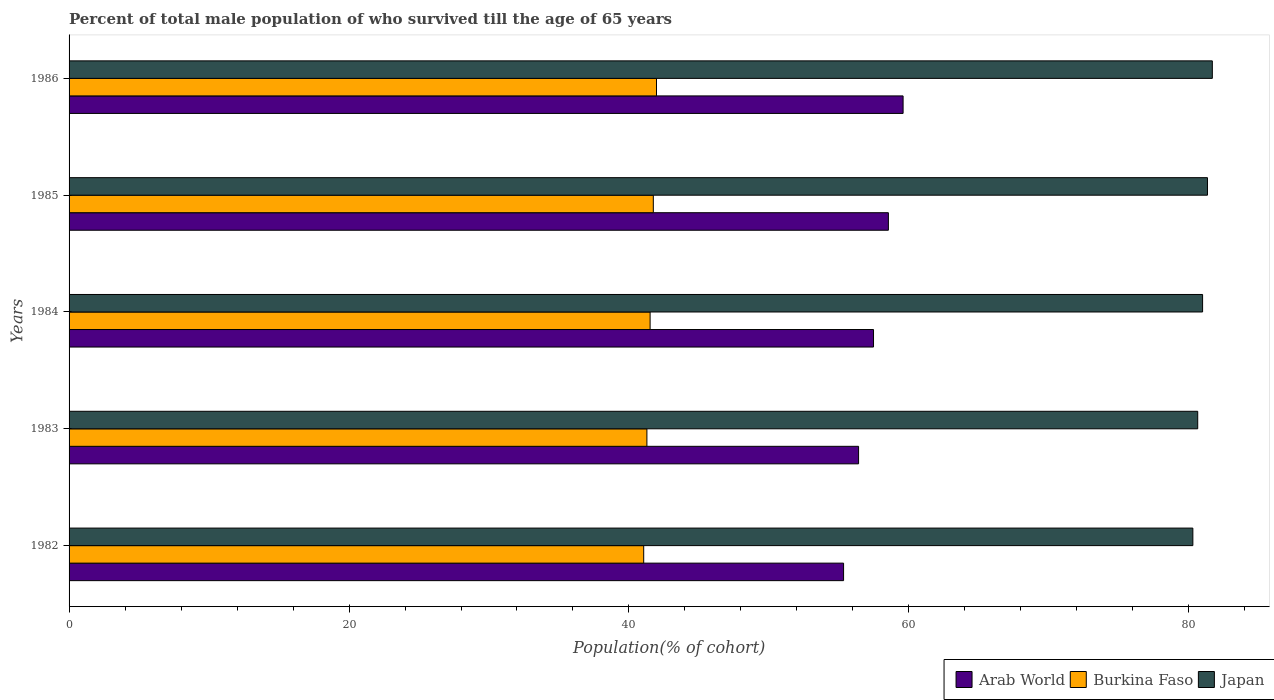Are the number of bars on each tick of the Y-axis equal?
Provide a short and direct response. Yes. How many bars are there on the 5th tick from the top?
Provide a succinct answer. 3. What is the label of the 3rd group of bars from the top?
Provide a succinct answer. 1984. What is the percentage of total male population who survived till the age of 65 years in Japan in 1985?
Ensure brevity in your answer.  81.33. Across all years, what is the maximum percentage of total male population who survived till the age of 65 years in Burkina Faso?
Provide a succinct answer. 41.97. Across all years, what is the minimum percentage of total male population who survived till the age of 65 years in Arab World?
Offer a terse response. 55.33. In which year was the percentage of total male population who survived till the age of 65 years in Japan maximum?
Offer a very short reply. 1986. What is the total percentage of total male population who survived till the age of 65 years in Arab World in the graph?
Offer a terse response. 287.32. What is the difference between the percentage of total male population who survived till the age of 65 years in Burkina Faso in 1984 and that in 1986?
Offer a very short reply. -0.46. What is the difference between the percentage of total male population who survived till the age of 65 years in Burkina Faso in 1983 and the percentage of total male population who survived till the age of 65 years in Japan in 1982?
Your answer should be very brief. -39. What is the average percentage of total male population who survived till the age of 65 years in Arab World per year?
Give a very brief answer. 57.46. In the year 1986, what is the difference between the percentage of total male population who survived till the age of 65 years in Burkina Faso and percentage of total male population who survived till the age of 65 years in Arab World?
Your answer should be compact. -17.62. What is the ratio of the percentage of total male population who survived till the age of 65 years in Arab World in 1982 to that in 1984?
Ensure brevity in your answer.  0.96. What is the difference between the highest and the second highest percentage of total male population who survived till the age of 65 years in Japan?
Keep it short and to the point. 0.35. What is the difference between the highest and the lowest percentage of total male population who survived till the age of 65 years in Arab World?
Provide a short and direct response. 4.25. Is it the case that in every year, the sum of the percentage of total male population who survived till the age of 65 years in Arab World and percentage of total male population who survived till the age of 65 years in Burkina Faso is greater than the percentage of total male population who survived till the age of 65 years in Japan?
Offer a terse response. Yes. Are the values on the major ticks of X-axis written in scientific E-notation?
Provide a succinct answer. No. Does the graph contain any zero values?
Offer a terse response. No. Does the graph contain grids?
Provide a short and direct response. No. Where does the legend appear in the graph?
Offer a very short reply. Bottom right. How many legend labels are there?
Keep it short and to the point. 3. How are the legend labels stacked?
Offer a terse response. Horizontal. What is the title of the graph?
Your answer should be compact. Percent of total male population of who survived till the age of 65 years. Does "Bahrain" appear as one of the legend labels in the graph?
Give a very brief answer. No. What is the label or title of the X-axis?
Provide a short and direct response. Population(% of cohort). What is the label or title of the Y-axis?
Ensure brevity in your answer.  Years. What is the Population(% of cohort) of Arab World in 1982?
Your answer should be very brief. 55.33. What is the Population(% of cohort) of Burkina Faso in 1982?
Provide a short and direct response. 41.05. What is the Population(% of cohort) in Japan in 1982?
Your answer should be compact. 80.29. What is the Population(% of cohort) in Arab World in 1983?
Make the answer very short. 56.4. What is the Population(% of cohort) of Burkina Faso in 1983?
Your answer should be very brief. 41.28. What is the Population(% of cohort) of Japan in 1983?
Keep it short and to the point. 80.63. What is the Population(% of cohort) of Arab World in 1984?
Provide a succinct answer. 57.47. What is the Population(% of cohort) in Burkina Faso in 1984?
Your answer should be compact. 41.51. What is the Population(% of cohort) in Japan in 1984?
Provide a short and direct response. 80.98. What is the Population(% of cohort) in Arab World in 1985?
Make the answer very short. 58.53. What is the Population(% of cohort) in Burkina Faso in 1985?
Provide a short and direct response. 41.74. What is the Population(% of cohort) of Japan in 1985?
Provide a short and direct response. 81.33. What is the Population(% of cohort) of Arab World in 1986?
Offer a very short reply. 59.58. What is the Population(% of cohort) in Burkina Faso in 1986?
Offer a very short reply. 41.97. What is the Population(% of cohort) of Japan in 1986?
Make the answer very short. 81.68. Across all years, what is the maximum Population(% of cohort) in Arab World?
Your answer should be compact. 59.58. Across all years, what is the maximum Population(% of cohort) of Burkina Faso?
Give a very brief answer. 41.97. Across all years, what is the maximum Population(% of cohort) of Japan?
Give a very brief answer. 81.68. Across all years, what is the minimum Population(% of cohort) of Arab World?
Provide a succinct answer. 55.33. Across all years, what is the minimum Population(% of cohort) in Burkina Faso?
Your response must be concise. 41.05. Across all years, what is the minimum Population(% of cohort) in Japan?
Offer a terse response. 80.29. What is the total Population(% of cohort) in Arab World in the graph?
Offer a terse response. 287.32. What is the total Population(% of cohort) in Burkina Faso in the graph?
Provide a short and direct response. 207.55. What is the total Population(% of cohort) of Japan in the graph?
Your response must be concise. 404.9. What is the difference between the Population(% of cohort) in Arab World in 1982 and that in 1983?
Provide a short and direct response. -1.07. What is the difference between the Population(% of cohort) in Burkina Faso in 1982 and that in 1983?
Provide a short and direct response. -0.23. What is the difference between the Population(% of cohort) of Japan in 1982 and that in 1983?
Your answer should be compact. -0.35. What is the difference between the Population(% of cohort) of Arab World in 1982 and that in 1984?
Offer a very short reply. -2.14. What is the difference between the Population(% of cohort) of Burkina Faso in 1982 and that in 1984?
Offer a very short reply. -0.46. What is the difference between the Population(% of cohort) in Japan in 1982 and that in 1984?
Your response must be concise. -0.7. What is the difference between the Population(% of cohort) in Arab World in 1982 and that in 1985?
Your answer should be very brief. -3.2. What is the difference between the Population(% of cohort) of Burkina Faso in 1982 and that in 1985?
Keep it short and to the point. -0.69. What is the difference between the Population(% of cohort) in Japan in 1982 and that in 1985?
Keep it short and to the point. -1.04. What is the difference between the Population(% of cohort) of Arab World in 1982 and that in 1986?
Offer a terse response. -4.25. What is the difference between the Population(% of cohort) in Burkina Faso in 1982 and that in 1986?
Keep it short and to the point. -0.91. What is the difference between the Population(% of cohort) of Japan in 1982 and that in 1986?
Provide a succinct answer. -1.39. What is the difference between the Population(% of cohort) of Arab World in 1983 and that in 1984?
Your answer should be very brief. -1.07. What is the difference between the Population(% of cohort) in Burkina Faso in 1983 and that in 1984?
Your answer should be compact. -0.23. What is the difference between the Population(% of cohort) of Japan in 1983 and that in 1984?
Provide a succinct answer. -0.35. What is the difference between the Population(% of cohort) in Arab World in 1983 and that in 1985?
Give a very brief answer. -2.13. What is the difference between the Population(% of cohort) of Burkina Faso in 1983 and that in 1985?
Keep it short and to the point. -0.46. What is the difference between the Population(% of cohort) in Japan in 1983 and that in 1985?
Provide a short and direct response. -0.7. What is the difference between the Population(% of cohort) of Arab World in 1983 and that in 1986?
Make the answer very short. -3.18. What is the difference between the Population(% of cohort) in Burkina Faso in 1983 and that in 1986?
Provide a short and direct response. -0.69. What is the difference between the Population(% of cohort) of Japan in 1983 and that in 1986?
Provide a succinct answer. -1.04. What is the difference between the Population(% of cohort) of Arab World in 1984 and that in 1985?
Your answer should be compact. -1.06. What is the difference between the Population(% of cohort) in Burkina Faso in 1984 and that in 1985?
Ensure brevity in your answer.  -0.23. What is the difference between the Population(% of cohort) in Japan in 1984 and that in 1985?
Your answer should be compact. -0.35. What is the difference between the Population(% of cohort) of Arab World in 1984 and that in 1986?
Ensure brevity in your answer.  -2.11. What is the difference between the Population(% of cohort) of Burkina Faso in 1984 and that in 1986?
Provide a succinct answer. -0.46. What is the difference between the Population(% of cohort) in Japan in 1984 and that in 1986?
Provide a short and direct response. -0.7. What is the difference between the Population(% of cohort) of Arab World in 1985 and that in 1986?
Provide a short and direct response. -1.05. What is the difference between the Population(% of cohort) in Burkina Faso in 1985 and that in 1986?
Make the answer very short. -0.23. What is the difference between the Population(% of cohort) in Japan in 1985 and that in 1986?
Your answer should be very brief. -0.35. What is the difference between the Population(% of cohort) of Arab World in 1982 and the Population(% of cohort) of Burkina Faso in 1983?
Provide a succinct answer. 14.05. What is the difference between the Population(% of cohort) in Arab World in 1982 and the Population(% of cohort) in Japan in 1983?
Offer a terse response. -25.3. What is the difference between the Population(% of cohort) of Burkina Faso in 1982 and the Population(% of cohort) of Japan in 1983?
Make the answer very short. -39.58. What is the difference between the Population(% of cohort) of Arab World in 1982 and the Population(% of cohort) of Burkina Faso in 1984?
Provide a succinct answer. 13.82. What is the difference between the Population(% of cohort) in Arab World in 1982 and the Population(% of cohort) in Japan in 1984?
Give a very brief answer. -25.65. What is the difference between the Population(% of cohort) in Burkina Faso in 1982 and the Population(% of cohort) in Japan in 1984?
Your answer should be very brief. -39.93. What is the difference between the Population(% of cohort) in Arab World in 1982 and the Population(% of cohort) in Burkina Faso in 1985?
Keep it short and to the point. 13.59. What is the difference between the Population(% of cohort) of Arab World in 1982 and the Population(% of cohort) of Japan in 1985?
Provide a succinct answer. -26. What is the difference between the Population(% of cohort) in Burkina Faso in 1982 and the Population(% of cohort) in Japan in 1985?
Give a very brief answer. -40.28. What is the difference between the Population(% of cohort) in Arab World in 1982 and the Population(% of cohort) in Burkina Faso in 1986?
Your response must be concise. 13.36. What is the difference between the Population(% of cohort) of Arab World in 1982 and the Population(% of cohort) of Japan in 1986?
Give a very brief answer. -26.34. What is the difference between the Population(% of cohort) in Burkina Faso in 1982 and the Population(% of cohort) in Japan in 1986?
Your response must be concise. -40.62. What is the difference between the Population(% of cohort) in Arab World in 1983 and the Population(% of cohort) in Burkina Faso in 1984?
Ensure brevity in your answer.  14.89. What is the difference between the Population(% of cohort) in Arab World in 1983 and the Population(% of cohort) in Japan in 1984?
Ensure brevity in your answer.  -24.58. What is the difference between the Population(% of cohort) in Burkina Faso in 1983 and the Population(% of cohort) in Japan in 1984?
Offer a very short reply. -39.7. What is the difference between the Population(% of cohort) in Arab World in 1983 and the Population(% of cohort) in Burkina Faso in 1985?
Keep it short and to the point. 14.66. What is the difference between the Population(% of cohort) in Arab World in 1983 and the Population(% of cohort) in Japan in 1985?
Offer a terse response. -24.93. What is the difference between the Population(% of cohort) of Burkina Faso in 1983 and the Population(% of cohort) of Japan in 1985?
Keep it short and to the point. -40.05. What is the difference between the Population(% of cohort) of Arab World in 1983 and the Population(% of cohort) of Burkina Faso in 1986?
Your response must be concise. 14.44. What is the difference between the Population(% of cohort) in Arab World in 1983 and the Population(% of cohort) in Japan in 1986?
Make the answer very short. -25.27. What is the difference between the Population(% of cohort) in Burkina Faso in 1983 and the Population(% of cohort) in Japan in 1986?
Give a very brief answer. -40.4. What is the difference between the Population(% of cohort) in Arab World in 1984 and the Population(% of cohort) in Burkina Faso in 1985?
Your response must be concise. 15.73. What is the difference between the Population(% of cohort) in Arab World in 1984 and the Population(% of cohort) in Japan in 1985?
Provide a succinct answer. -23.86. What is the difference between the Population(% of cohort) of Burkina Faso in 1984 and the Population(% of cohort) of Japan in 1985?
Ensure brevity in your answer.  -39.82. What is the difference between the Population(% of cohort) in Arab World in 1984 and the Population(% of cohort) in Burkina Faso in 1986?
Provide a succinct answer. 15.5. What is the difference between the Population(% of cohort) in Arab World in 1984 and the Population(% of cohort) in Japan in 1986?
Provide a succinct answer. -24.21. What is the difference between the Population(% of cohort) of Burkina Faso in 1984 and the Population(% of cohort) of Japan in 1986?
Make the answer very short. -40.17. What is the difference between the Population(% of cohort) in Arab World in 1985 and the Population(% of cohort) in Burkina Faso in 1986?
Provide a succinct answer. 16.57. What is the difference between the Population(% of cohort) in Arab World in 1985 and the Population(% of cohort) in Japan in 1986?
Ensure brevity in your answer.  -23.14. What is the difference between the Population(% of cohort) in Burkina Faso in 1985 and the Population(% of cohort) in Japan in 1986?
Ensure brevity in your answer.  -39.94. What is the average Population(% of cohort) of Arab World per year?
Your answer should be very brief. 57.46. What is the average Population(% of cohort) in Burkina Faso per year?
Your answer should be very brief. 41.51. What is the average Population(% of cohort) of Japan per year?
Offer a terse response. 80.98. In the year 1982, what is the difference between the Population(% of cohort) in Arab World and Population(% of cohort) in Burkina Faso?
Ensure brevity in your answer.  14.28. In the year 1982, what is the difference between the Population(% of cohort) of Arab World and Population(% of cohort) of Japan?
Offer a terse response. -24.95. In the year 1982, what is the difference between the Population(% of cohort) in Burkina Faso and Population(% of cohort) in Japan?
Keep it short and to the point. -39.23. In the year 1983, what is the difference between the Population(% of cohort) of Arab World and Population(% of cohort) of Burkina Faso?
Provide a succinct answer. 15.12. In the year 1983, what is the difference between the Population(% of cohort) in Arab World and Population(% of cohort) in Japan?
Provide a short and direct response. -24.23. In the year 1983, what is the difference between the Population(% of cohort) of Burkina Faso and Population(% of cohort) of Japan?
Ensure brevity in your answer.  -39.35. In the year 1984, what is the difference between the Population(% of cohort) of Arab World and Population(% of cohort) of Burkina Faso?
Offer a terse response. 15.96. In the year 1984, what is the difference between the Population(% of cohort) in Arab World and Population(% of cohort) in Japan?
Make the answer very short. -23.51. In the year 1984, what is the difference between the Population(% of cohort) of Burkina Faso and Population(% of cohort) of Japan?
Keep it short and to the point. -39.47. In the year 1985, what is the difference between the Population(% of cohort) of Arab World and Population(% of cohort) of Burkina Faso?
Your response must be concise. 16.79. In the year 1985, what is the difference between the Population(% of cohort) of Arab World and Population(% of cohort) of Japan?
Give a very brief answer. -22.8. In the year 1985, what is the difference between the Population(% of cohort) in Burkina Faso and Population(% of cohort) in Japan?
Provide a short and direct response. -39.59. In the year 1986, what is the difference between the Population(% of cohort) of Arab World and Population(% of cohort) of Burkina Faso?
Your response must be concise. 17.62. In the year 1986, what is the difference between the Population(% of cohort) in Arab World and Population(% of cohort) in Japan?
Your answer should be very brief. -22.09. In the year 1986, what is the difference between the Population(% of cohort) in Burkina Faso and Population(% of cohort) in Japan?
Make the answer very short. -39.71. What is the ratio of the Population(% of cohort) in Burkina Faso in 1982 to that in 1983?
Provide a succinct answer. 0.99. What is the ratio of the Population(% of cohort) in Japan in 1982 to that in 1983?
Your answer should be compact. 1. What is the ratio of the Population(% of cohort) in Arab World in 1982 to that in 1984?
Give a very brief answer. 0.96. What is the ratio of the Population(% of cohort) in Japan in 1982 to that in 1984?
Ensure brevity in your answer.  0.99. What is the ratio of the Population(% of cohort) of Arab World in 1982 to that in 1985?
Keep it short and to the point. 0.95. What is the ratio of the Population(% of cohort) in Burkina Faso in 1982 to that in 1985?
Ensure brevity in your answer.  0.98. What is the ratio of the Population(% of cohort) of Japan in 1982 to that in 1985?
Make the answer very short. 0.99. What is the ratio of the Population(% of cohort) of Burkina Faso in 1982 to that in 1986?
Your answer should be very brief. 0.98. What is the ratio of the Population(% of cohort) of Arab World in 1983 to that in 1984?
Your answer should be compact. 0.98. What is the ratio of the Population(% of cohort) of Burkina Faso in 1983 to that in 1984?
Your response must be concise. 0.99. What is the ratio of the Population(% of cohort) of Arab World in 1983 to that in 1985?
Your answer should be very brief. 0.96. What is the ratio of the Population(% of cohort) of Burkina Faso in 1983 to that in 1985?
Offer a very short reply. 0.99. What is the ratio of the Population(% of cohort) of Japan in 1983 to that in 1985?
Offer a terse response. 0.99. What is the ratio of the Population(% of cohort) in Arab World in 1983 to that in 1986?
Keep it short and to the point. 0.95. What is the ratio of the Population(% of cohort) in Burkina Faso in 1983 to that in 1986?
Offer a terse response. 0.98. What is the ratio of the Population(% of cohort) in Japan in 1983 to that in 1986?
Provide a short and direct response. 0.99. What is the ratio of the Population(% of cohort) of Arab World in 1984 to that in 1985?
Your answer should be compact. 0.98. What is the ratio of the Population(% of cohort) of Burkina Faso in 1984 to that in 1985?
Give a very brief answer. 0.99. What is the ratio of the Population(% of cohort) in Japan in 1984 to that in 1985?
Give a very brief answer. 1. What is the ratio of the Population(% of cohort) of Arab World in 1984 to that in 1986?
Provide a succinct answer. 0.96. What is the ratio of the Population(% of cohort) of Japan in 1984 to that in 1986?
Your answer should be very brief. 0.99. What is the ratio of the Population(% of cohort) in Arab World in 1985 to that in 1986?
Provide a short and direct response. 0.98. What is the ratio of the Population(% of cohort) of Japan in 1985 to that in 1986?
Your answer should be very brief. 1. What is the difference between the highest and the second highest Population(% of cohort) of Arab World?
Ensure brevity in your answer.  1.05. What is the difference between the highest and the second highest Population(% of cohort) in Burkina Faso?
Your answer should be very brief. 0.23. What is the difference between the highest and the second highest Population(% of cohort) of Japan?
Ensure brevity in your answer.  0.35. What is the difference between the highest and the lowest Population(% of cohort) in Arab World?
Provide a succinct answer. 4.25. What is the difference between the highest and the lowest Population(% of cohort) of Burkina Faso?
Provide a succinct answer. 0.91. What is the difference between the highest and the lowest Population(% of cohort) in Japan?
Offer a very short reply. 1.39. 